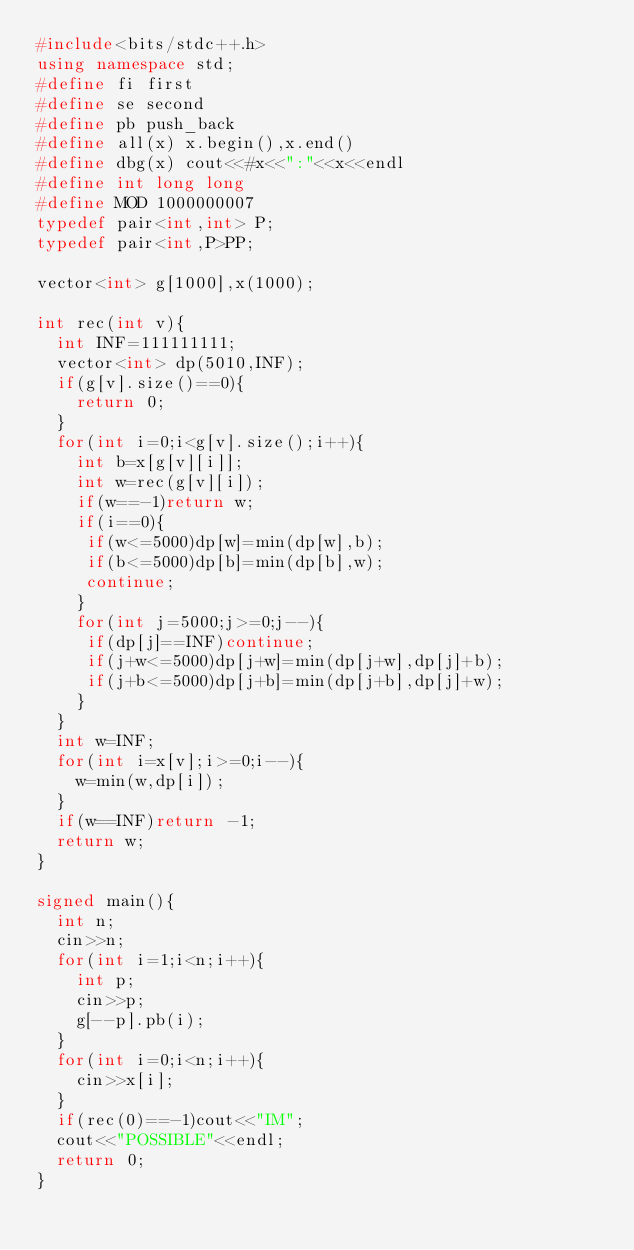Convert code to text. <code><loc_0><loc_0><loc_500><loc_500><_C++_>#include<bits/stdc++.h>
using namespace std;
#define fi first
#define se second
#define pb push_back
#define all(x) x.begin(),x.end()
#define dbg(x) cout<<#x<<":"<<x<<endl
#define int long long
#define MOD 1000000007
typedef pair<int,int> P;
typedef pair<int,P>PP;

vector<int> g[1000],x(1000);

int rec(int v){
  int INF=111111111;
  vector<int> dp(5010,INF);
  if(g[v].size()==0){
    return 0;
  }
  for(int i=0;i<g[v].size();i++){
    int b=x[g[v][i]];
    int w=rec(g[v][i]);
    if(w==-1)return w;
    if(i==0){
	 if(w<=5000)dp[w]=min(dp[w],b);
	 if(b<=5000)dp[b]=min(dp[b],w);
	 continue;
    }
    for(int j=5000;j>=0;j--){
	 if(dp[j]==INF)continue;
	 if(j+w<=5000)dp[j+w]=min(dp[j+w],dp[j]+b);
	 if(j+b<=5000)dp[j+b]=min(dp[j+b],dp[j]+w);
    }
  }
  int w=INF;
  for(int i=x[v];i>=0;i--){
    w=min(w,dp[i]);
  }
  if(w==INF)return -1;
  return w;
}

signed main(){
  int n;
  cin>>n;
  for(int i=1;i<n;i++){
    int p;
    cin>>p;
    g[--p].pb(i);
  }
  for(int i=0;i<n;i++){
    cin>>x[i];
  }
  if(rec(0)==-1)cout<<"IM";
  cout<<"POSSIBLE"<<endl;
  return 0;
}
</code> 